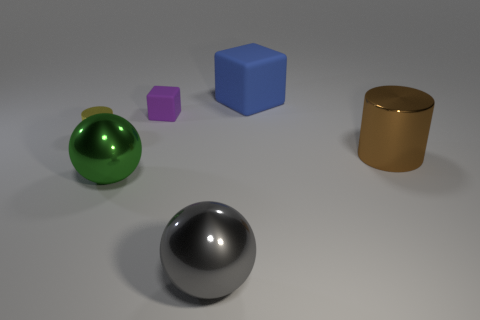Can you tell me which objects have a circular shape? Certainly. In the displayed image, both the shiny silver sphere at the forefront and the green spherical object have a circular shape. 